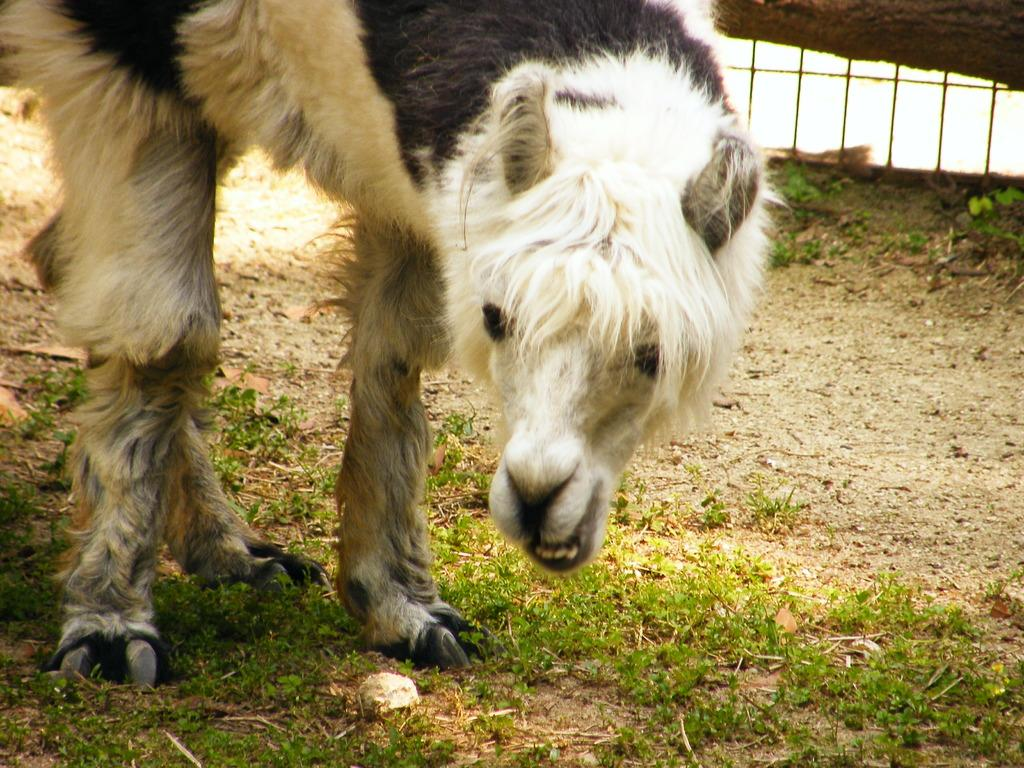What type of animal is in the image? The animal appears to be a camel. What is the camel standing on? The camel is standing on a grass surface. Can you describe any background elements in the image? There is a part of a railing visible in the background of the image. What type of government is depicted in the image? There is no government depicted in the image; it features a camel standing on a grass surface with a railing visible in the background. What flavor of cake is being served at the camel's party in the image? There is no cake or party present in the image; it features a camel standing on a grass surface with a railing visible in the background. 